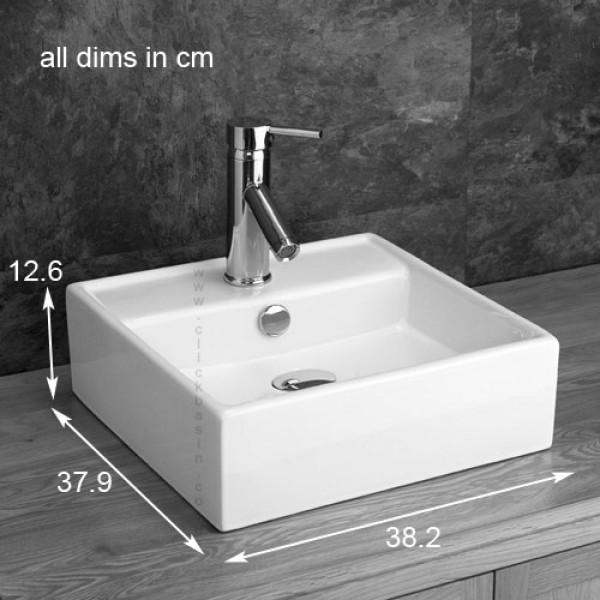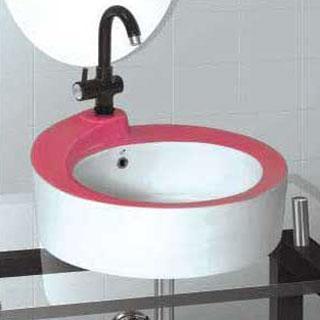The first image is the image on the left, the second image is the image on the right. Considering the images on both sides, is "The sink on the left is a circular shape with a white interior" valid? Answer yes or no. No. The first image is the image on the left, the second image is the image on the right. Assess this claim about the two images: "One sink has a round basin and features a two-tone design that includes a bright color.". Correct or not? Answer yes or no. Yes. 